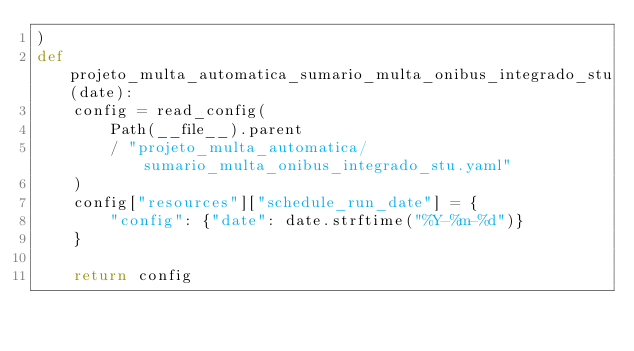<code> <loc_0><loc_0><loc_500><loc_500><_Python_>)
def projeto_multa_automatica_sumario_multa_onibus_integrado_stu(date):
    config = read_config(
        Path(__file__).parent
        / "projeto_multa_automatica/sumario_multa_onibus_integrado_stu.yaml"
    )
    config["resources"]["schedule_run_date"] = {
        "config": {"date": date.strftime("%Y-%m-%d")}
    }

    return config
</code> 